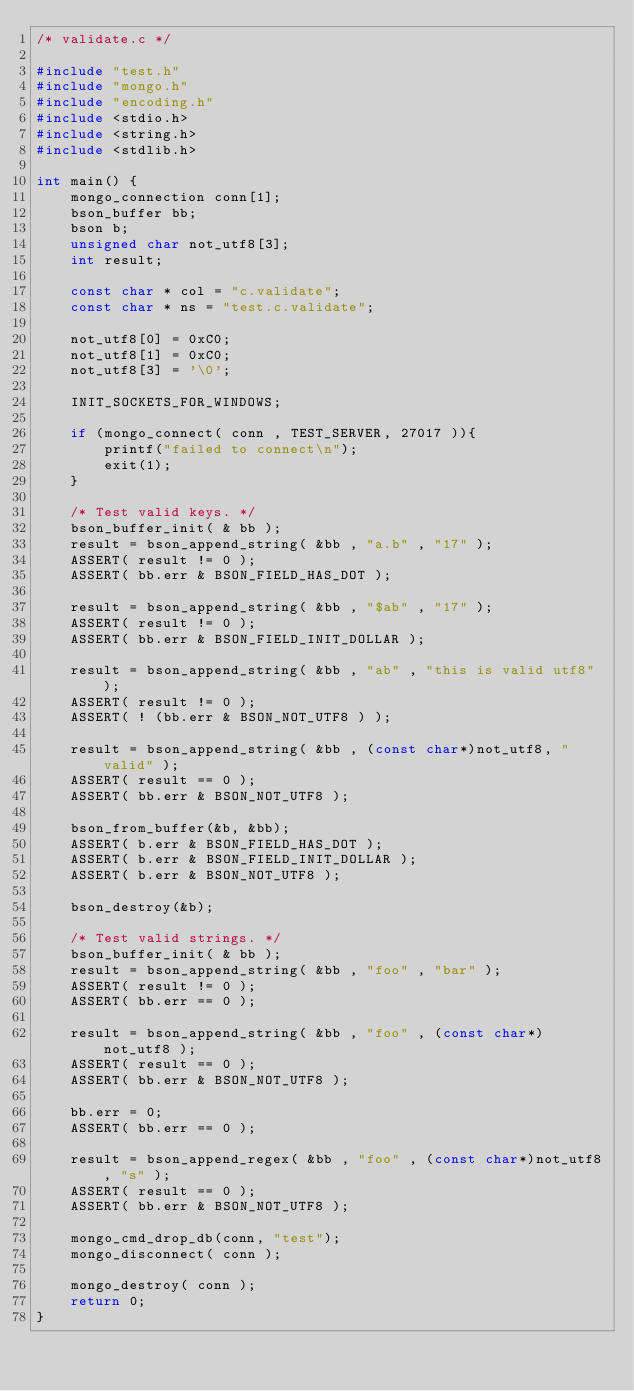<code> <loc_0><loc_0><loc_500><loc_500><_C_>/* validate.c */

#include "test.h"
#include "mongo.h"
#include "encoding.h"
#include <stdio.h>
#include <string.h>
#include <stdlib.h>

int main() {
    mongo_connection conn[1];
    bson_buffer bb;
    bson b;
    unsigned char not_utf8[3];
    int result;

    const char * col = "c.validate";
    const char * ns = "test.c.validate";

    not_utf8[0] = 0xC0;
    not_utf8[1] = 0xC0;
    not_utf8[3] = '\0';

    INIT_SOCKETS_FOR_WINDOWS;

    if (mongo_connect( conn , TEST_SERVER, 27017 )){
        printf("failed to connect\n");
        exit(1);
    }

    /* Test valid keys. */
    bson_buffer_init( & bb );
    result = bson_append_string( &bb , "a.b" , "17" );
    ASSERT( result != 0 );
    ASSERT( bb.err & BSON_FIELD_HAS_DOT );

    result = bson_append_string( &bb , "$ab" , "17" );
    ASSERT( result != 0 );
    ASSERT( bb.err & BSON_FIELD_INIT_DOLLAR );

    result = bson_append_string( &bb , "ab" , "this is valid utf8" );
    ASSERT( result != 0 );
    ASSERT( ! (bb.err & BSON_NOT_UTF8 ) );

    result = bson_append_string( &bb , (const char*)not_utf8, "valid" );
    ASSERT( result == 0 );
    ASSERT( bb.err & BSON_NOT_UTF8 );

    bson_from_buffer(&b, &bb);
    ASSERT( b.err & BSON_FIELD_HAS_DOT );
    ASSERT( b.err & BSON_FIELD_INIT_DOLLAR );
    ASSERT( b.err & BSON_NOT_UTF8 );

    bson_destroy(&b);

    /* Test valid strings. */
    bson_buffer_init( & bb );
    result = bson_append_string( &bb , "foo" , "bar" );
    ASSERT( result != 0 );
    ASSERT( bb.err == 0 );

    result = bson_append_string( &bb , "foo" , (const char*)not_utf8 );
    ASSERT( result == 0 );
    ASSERT( bb.err & BSON_NOT_UTF8 );

    bb.err = 0;
    ASSERT( bb.err == 0 );

    result = bson_append_regex( &bb , "foo" , (const char*)not_utf8, "s" );
    ASSERT( result == 0 );
    ASSERT( bb.err & BSON_NOT_UTF8 );

    mongo_cmd_drop_db(conn, "test");
    mongo_disconnect( conn );

    mongo_destroy( conn );
    return 0;
}
</code> 